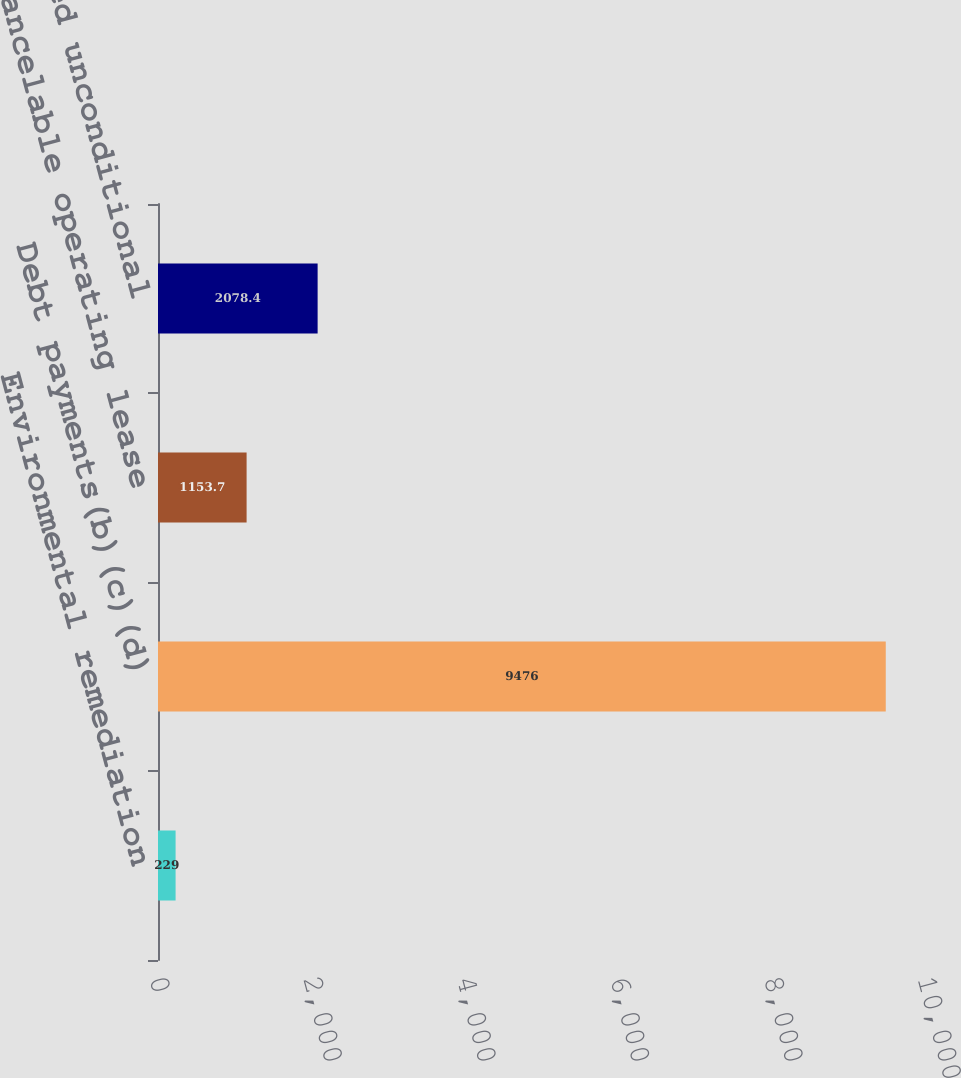Convert chart to OTSL. <chart><loc_0><loc_0><loc_500><loc_500><bar_chart><fcel>Environmental remediation<fcel>Debt payments(b)(c)(d)<fcel>Non-cancelable operating lease<fcel>Estimated unconditional<nl><fcel>229<fcel>9476<fcel>1153.7<fcel>2078.4<nl></chart> 